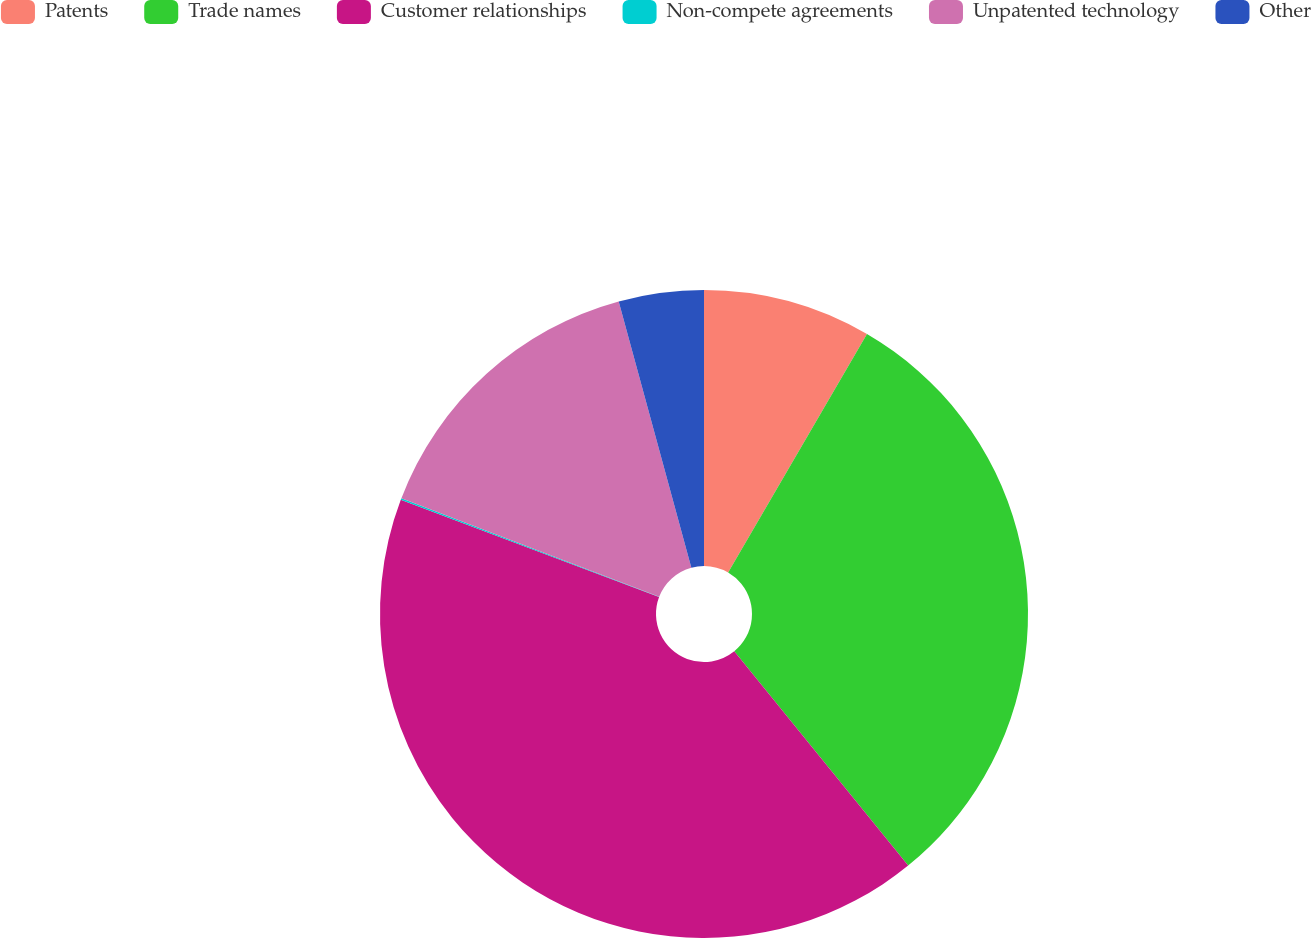Convert chart to OTSL. <chart><loc_0><loc_0><loc_500><loc_500><pie_chart><fcel>Patents<fcel>Trade names<fcel>Customer relationships<fcel>Non-compete agreements<fcel>Unpatented technology<fcel>Other<nl><fcel>8.39%<fcel>30.76%<fcel>41.58%<fcel>0.09%<fcel>14.94%<fcel>4.24%<nl></chart> 